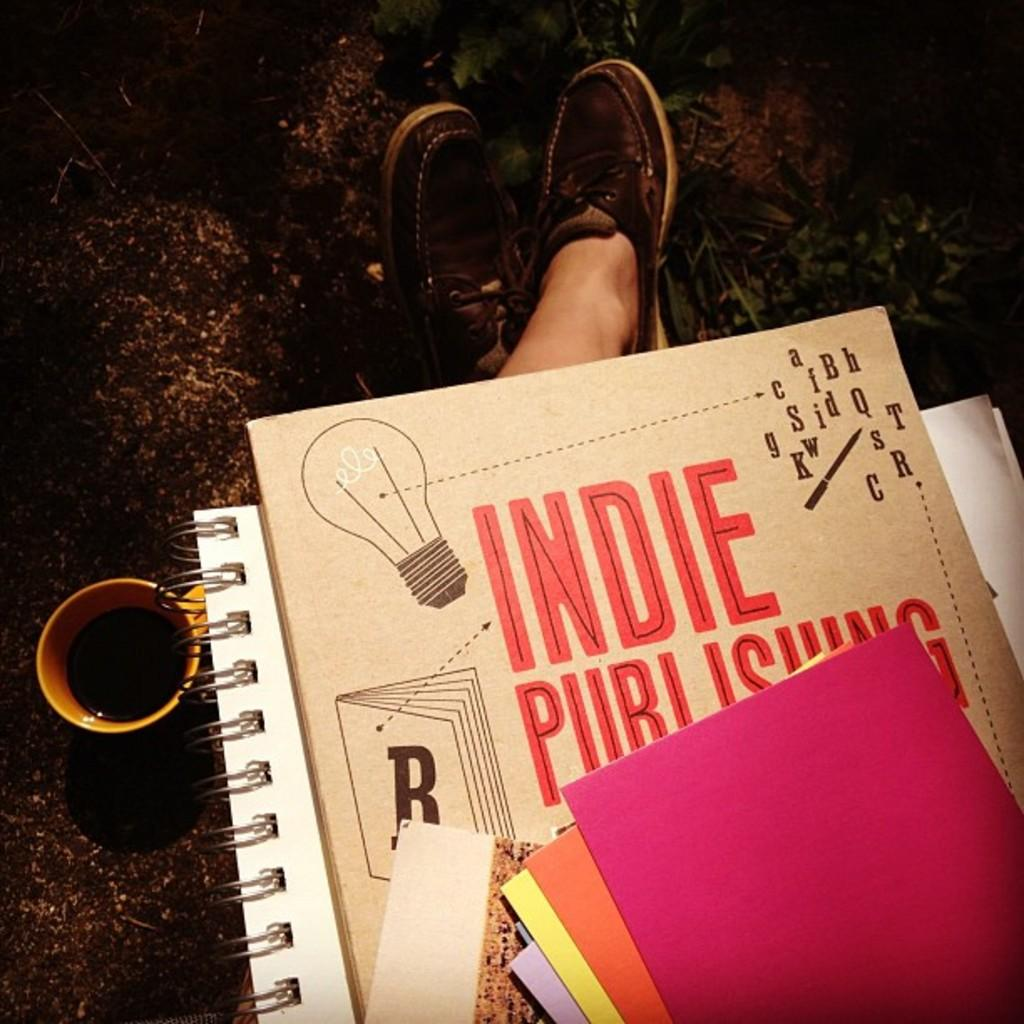<image>
Render a clear and concise summary of the photo. A person is sitting in dirt with a mug of coffee and a pile of books that say Indie Publishing. 